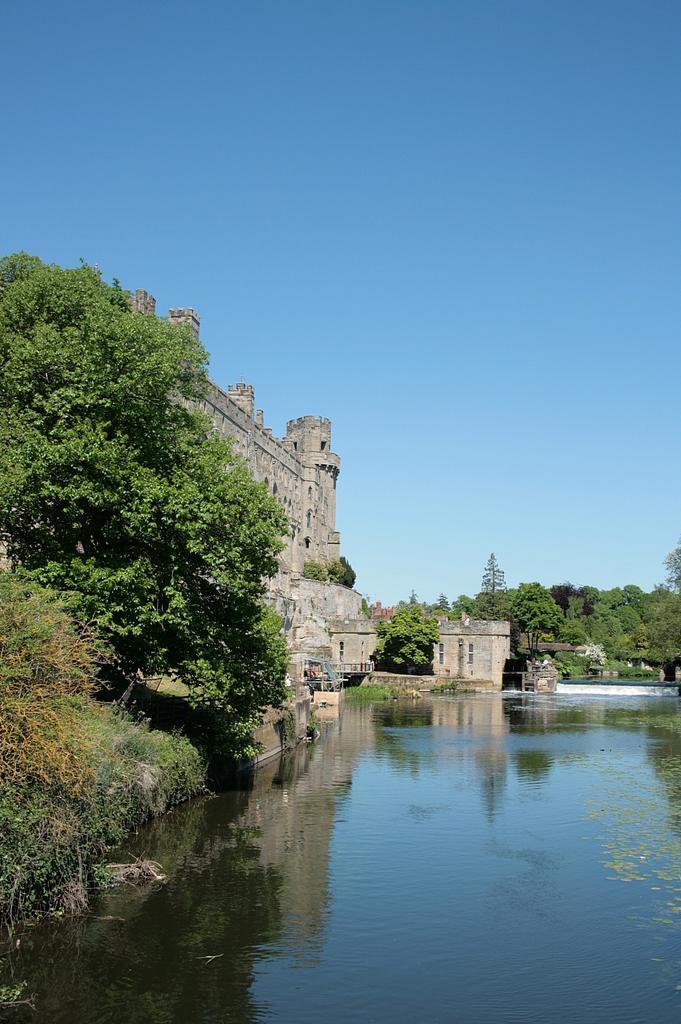How would you summarize this image in a sentence or two? In this image we can see the building and trees and in front of the building we can see the water. In the background, we can see the sky. 